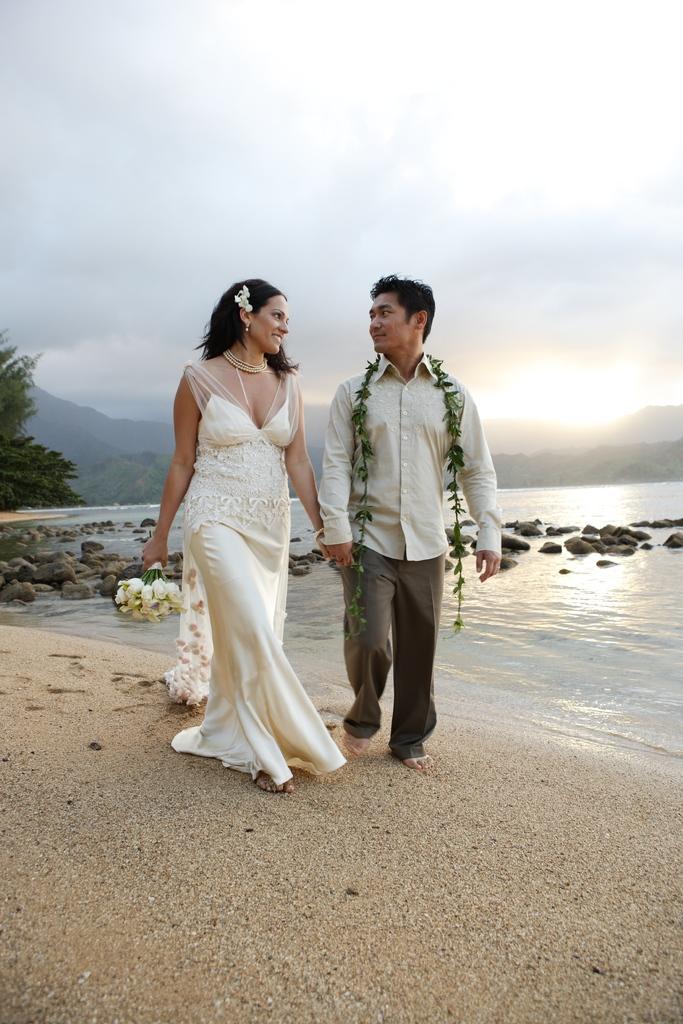Could you give a brief overview of what you see in this image? In the picture I can see a couple walking on sand and holding a hand of each other and there is water and few rocks behind them and there are trees and mountains in the background. 